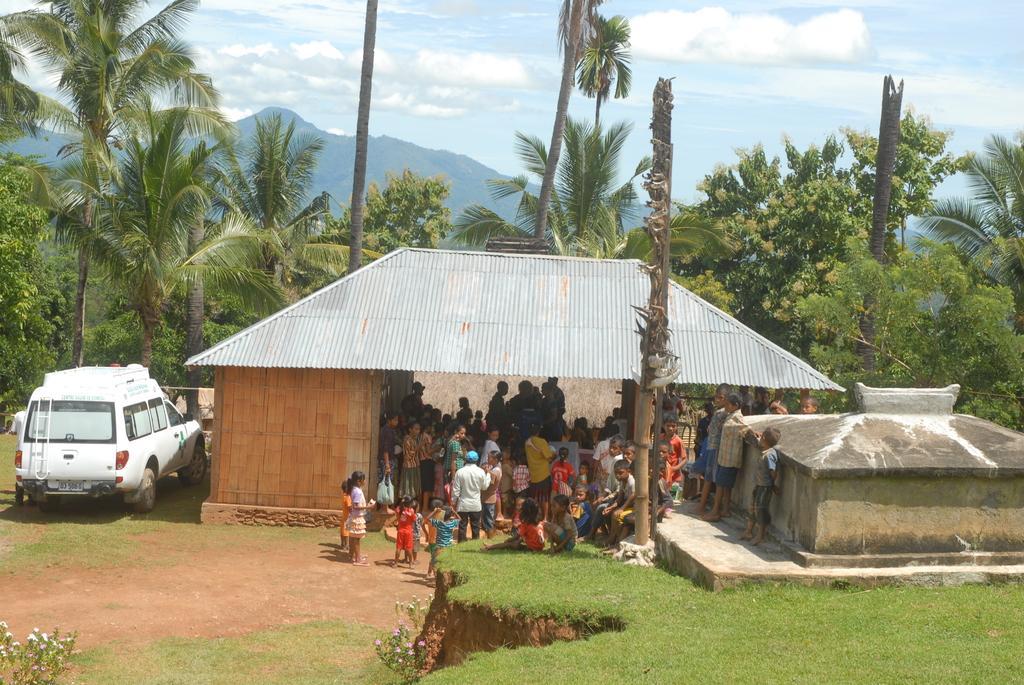Could you give a brief overview of what you see in this image? In this image I can see few people are under the shed. These people are wearing the different color dresses. To the side of the shed I can see the car which is in white color. In the background there are many trees, mountains, clouds and the blue sky. 